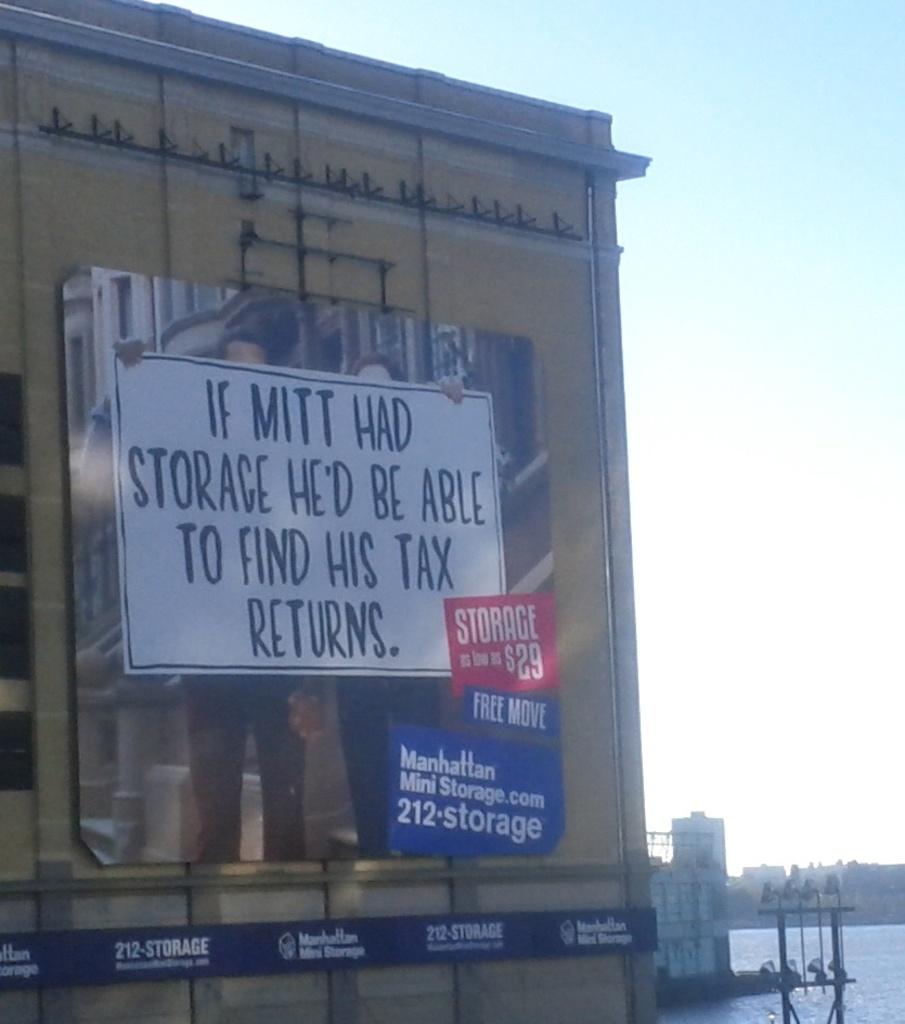What city is the mini storage located in?
Keep it short and to the point. Manhattan. Who'd be able to find their tax returns?
Make the answer very short. Mitt. 